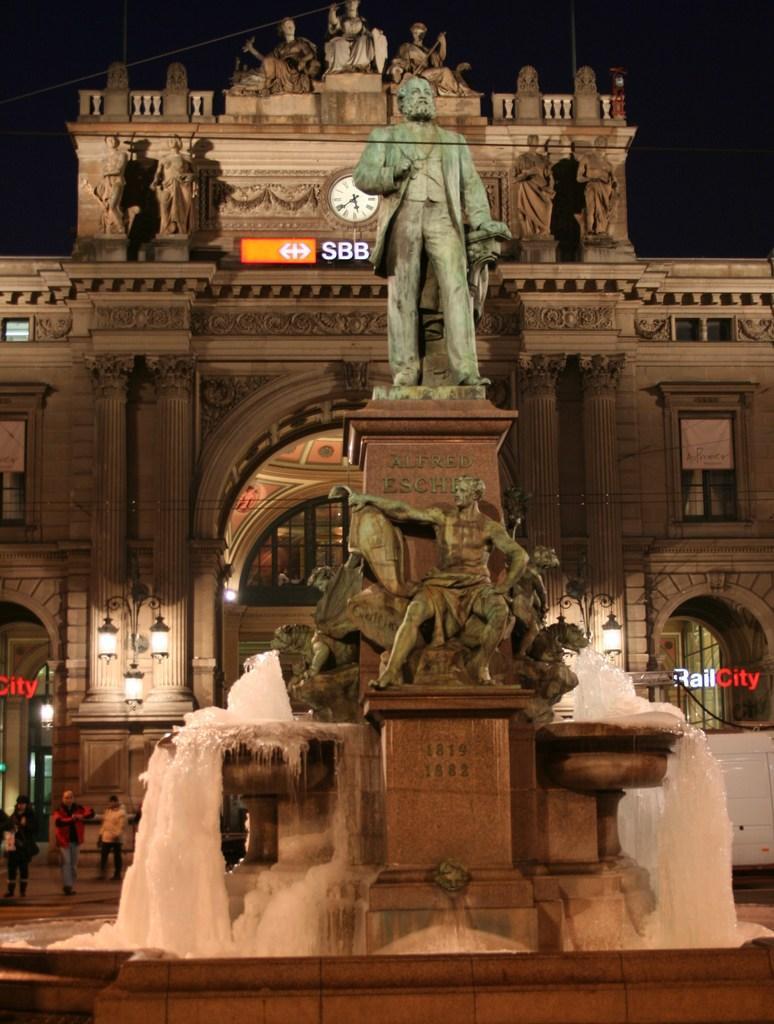How would you summarize this image in a sentence or two? In this image in front there is a fountain. There are statues. Behind the fountain there are people. There are lights. In the background of the image there is a building and there is sky. 